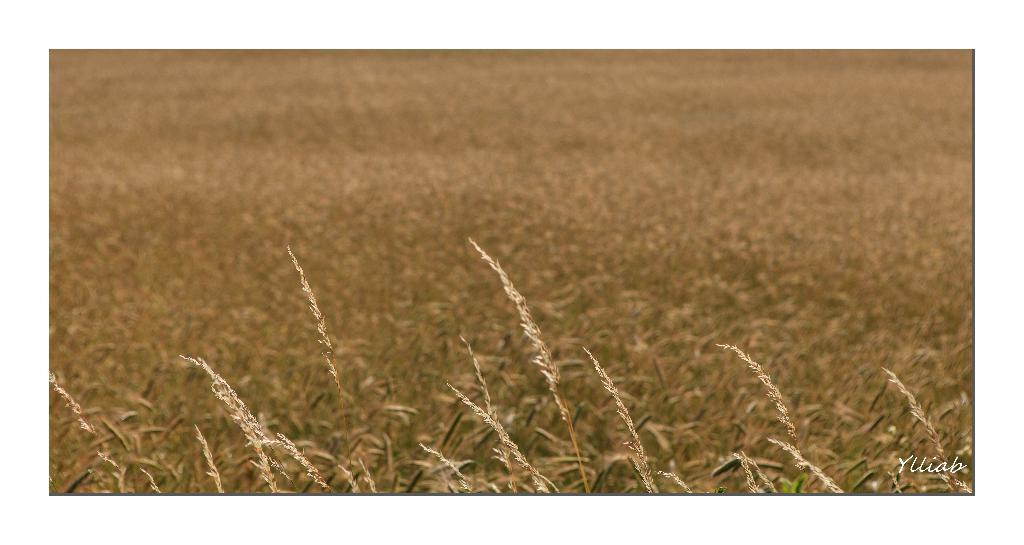What is the main setting of the image? The image depicts a field. What can be found in the field? There are plants in the field. How many ice cubes are scattered across the field in the image? There are no ice cubes present in the image; it features a field with plants. What type of parcel can be seen being pushed through the field in the image? There is no parcel or pushing action depicted in the image; it only shows a field with plants. 